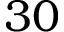<formula> <loc_0><loc_0><loc_500><loc_500>3 0</formula> 